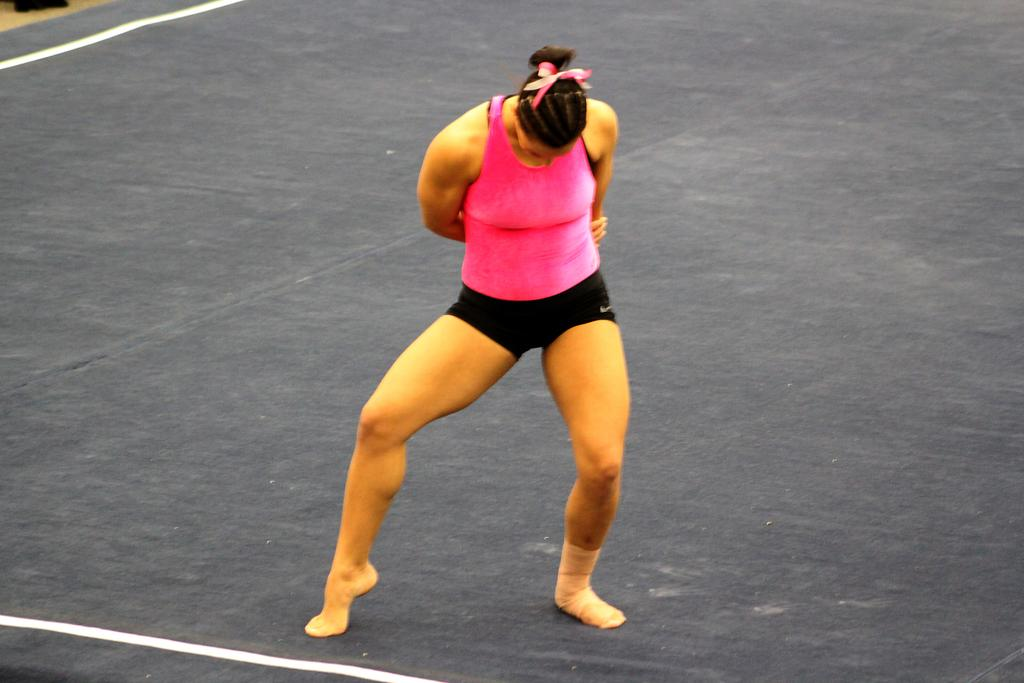Who is present in the image? There is a woman in the image. What is the woman wearing on her upper body? The woman is wearing a pink top. What is the woman wearing on her lower body? The woman is wearing black shorts. What can be seen in the background of the image? There is a path in the image. What is the color of the path? The path is black in color. What additional detail can be observed on the path? There are white lines on the path. What type of ornament is hanging from the woman's neck in the image? There is no ornament visible around the woman's neck in the image. How many cushions are present on the path in the image? There are no cushions present on the path in the image. 